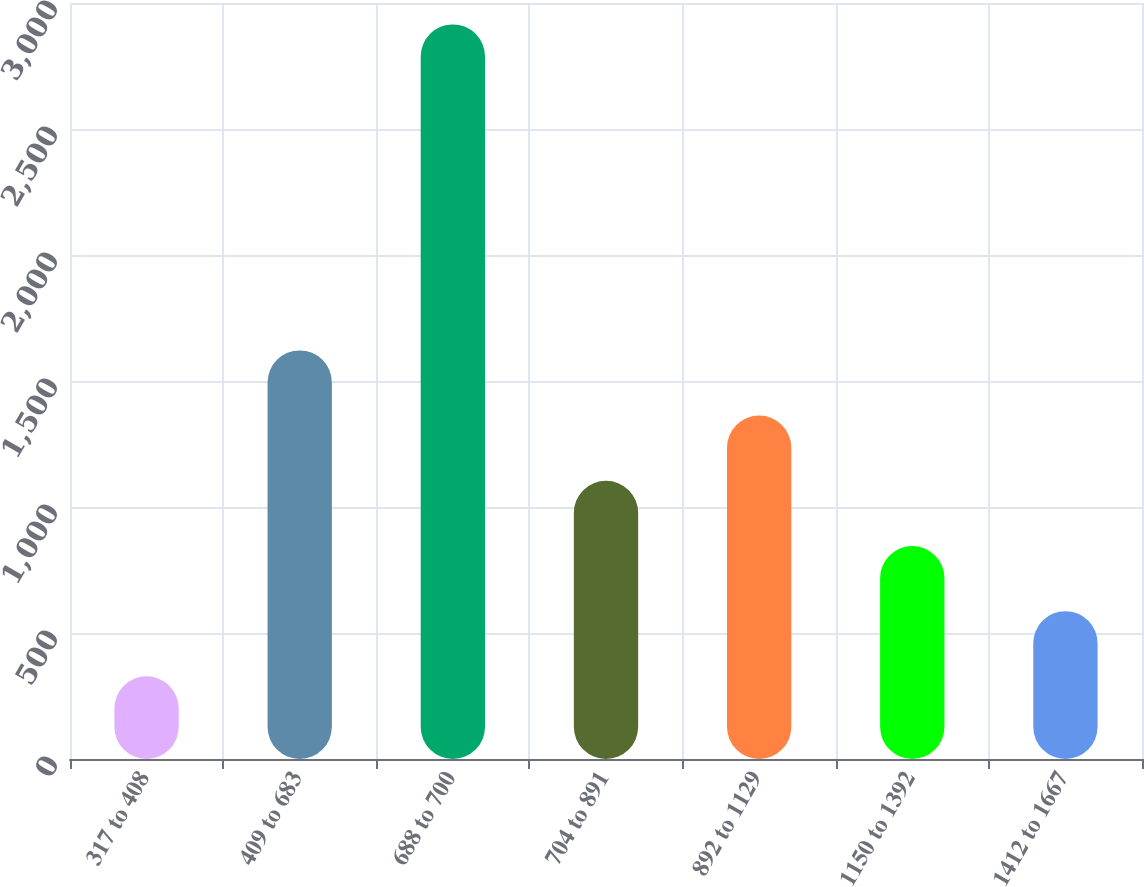<chart> <loc_0><loc_0><loc_500><loc_500><bar_chart><fcel>317 to 408<fcel>409 to 683<fcel>688 to 700<fcel>704 to 891<fcel>892 to 1129<fcel>1150 to 1392<fcel>1412 to 1667<nl><fcel>328<fcel>1621.5<fcel>2915<fcel>1104.1<fcel>1362.8<fcel>845.4<fcel>586.7<nl></chart> 